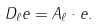<formula> <loc_0><loc_0><loc_500><loc_500>D _ { \ell } e = A _ { \ell } \cdot e .</formula> 